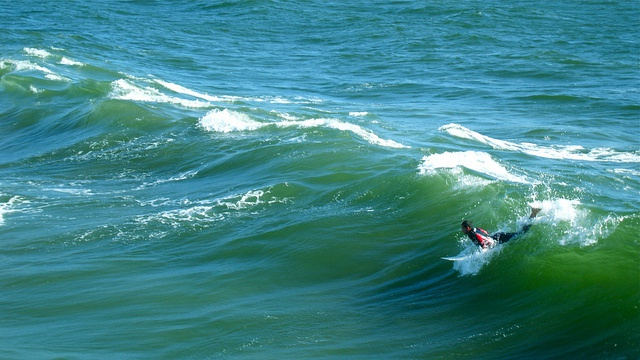Describe the objects in this image and their specific colors. I can see people in teal and black tones and surfboard in teal and lightblue tones in this image. 